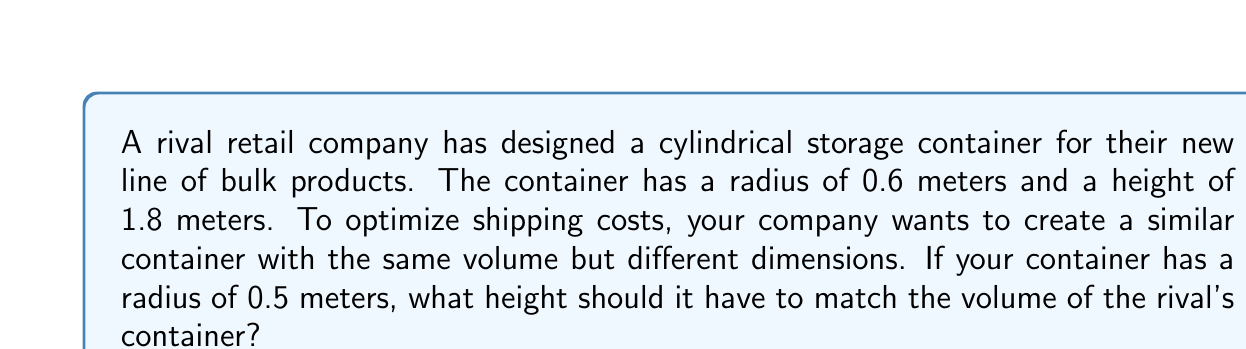Teach me how to tackle this problem. To solve this problem, we need to follow these steps:

1. Calculate the volume of the rival's container:
   The volume of a cylinder is given by the formula:
   $$V = \pi r^2 h$$
   where $r$ is the radius and $h$ is the height.

   For the rival's container:
   $$V_{rival} = \pi (0.6\text{ m})^2 (1.8\text{ m})$$
   $$V_{rival} = \pi (0.36\text{ m}^2) (1.8\text{ m})$$
   $$V_{rival} = 2.0358\text{ m}^3$$

2. Set up an equation for your container:
   We want the volume of your container to be equal to the rival's:
   $$V_{your} = V_{rival}$$
   $$\pi r_{your}^2 h_{your} = 2.0358\text{ m}^3$$

3. Substitute the known radius of your container:
   $$\pi (0.5\text{ m})^2 h_{your} = 2.0358\text{ m}^3$$

4. Solve for $h_{your}$:
   $$\pi (0.25\text{ m}^2) h_{your} = 2.0358\text{ m}^3$$
   $$0.7854\text{ m}^2 \cdot h_{your} = 2.0358\text{ m}^3$$
   $$h_{your} = \frac{2.0358\text{ m}^3}{0.7854\text{ m}^2}$$
   $$h_{your} = 2.5920\text{ m}$$

Therefore, your container should have a height of approximately 2.5920 meters to match the volume of the rival's container.
Answer: $2.5920\text{ m}$ 